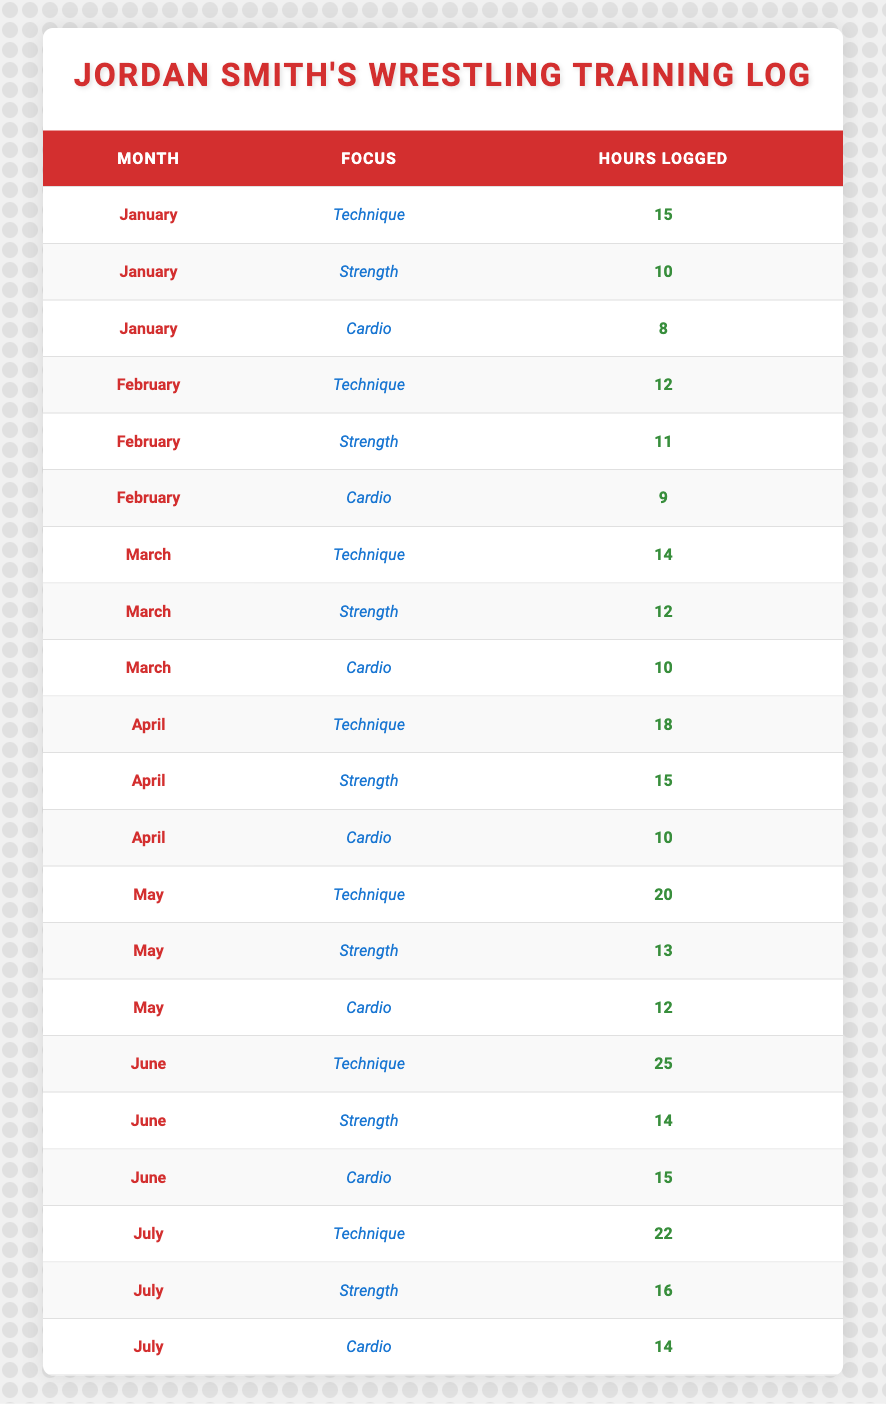What are the total hours logged by Jordan Smith for strength training in January? In January, there are three entries for Jordan Smith's training sessions: Technique (15 hours), Strength (10 hours), and Cardio (8 hours). The total hours logged for strength training specifically is 10 hours.
Answer: 10 Which month had the highest recorded hours for technique training? By examining the table, the hours logged for technique training are as follows: January (15), February (12), March (14), April (18), May (20), June (25), and July (22). The highest hours are in June with 25 hours.
Answer: 25 Did Jordan Smith log more hours in strength training than cardio in April? In April, the hours for strength training are 15, and for cardio, they are 10. Comparing these values, 15 is greater than 10, confirming that Jordan Smith logged more strength training hours than cardio in April.
Answer: Yes What is the average number of hours logged by Jordan Smith for cardio training from January to July? The hours logged for cardio training are: January (8), February (9), March (10), April (10), May (12), June (15), and July (14). To find the average, we first sum the hours: 8 + 9 + 10 + 10 + 12 + 15 + 14 = 78 hours. Dividing by 7 (the number of months): 78 / 7 = approximately 11.14 hours.
Answer: 11.14 In which month did Jordan Smith log the least total hours across all training focuses? To determine the month with the least total hours, we need to calculate total hours for each month: January (33), February (32), March (36), April (43), May (45), June (54), and July (52). The least total hours logged is in February with 32 hours.
Answer: February What was the difference in hours logged for technique training between June and March? The hours for technique training in June are 25, while in March, they are 14. To find the difference: 25 - 14 = 11 hours. Thus, the difference in hours logged for technique training between these months is 11.
Answer: 11 How many hours did Jordan Smith log in total for strength training from January to July? The total hours logged for strength training are: January (10), February (11), March (12), April (15), May (13), June (14), and July (16). Summing them: 10 + 11 + 12 + 15 + 13 + 14 + 16 = 91 hours.
Answer: 91 Is there any month where Jordan Smith logged exactly 16 hours of strength training? Looking at the data for strength training across all months: January (10), February (11), March (12), April (15), May (13), June (14), and July (16). Since July has 16 hours, the answer is yes.
Answer: Yes In which month did Jordan Smith devote the most total hours across all training focuses? To find the month with the most total hours, adding across focuses gives: January (33), February (32), March (36), April (43), May (45), June (54), and July (52). The month with the highest total hours is June with 54 hours.
Answer: June 